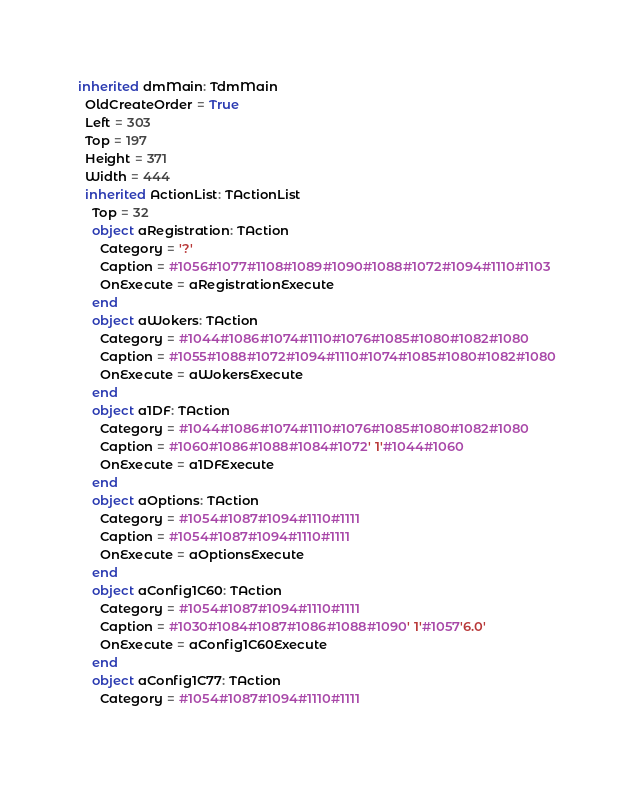Convert code to text. <code><loc_0><loc_0><loc_500><loc_500><_Pascal_>inherited dmMain: TdmMain
  OldCreateOrder = True
  Left = 303
  Top = 197
  Height = 371
  Width = 444
  inherited ActionList: TActionList
    Top = 32
    object aRegistration: TAction
      Category = '?'
      Caption = #1056#1077#1108#1089#1090#1088#1072#1094#1110#1103
      OnExecute = aRegistrationExecute
    end
    object aWokers: TAction
      Category = #1044#1086#1074#1110#1076#1085#1080#1082#1080
      Caption = #1055#1088#1072#1094#1110#1074#1085#1080#1082#1080
      OnExecute = aWokersExecute
    end
    object a1DF: TAction
      Category = #1044#1086#1074#1110#1076#1085#1080#1082#1080
      Caption = #1060#1086#1088#1084#1072' 1'#1044#1060
      OnExecute = a1DFExecute
    end
    object aOptions: TAction
      Category = #1054#1087#1094#1110#1111
      Caption = #1054#1087#1094#1110#1111
      OnExecute = aOptionsExecute
    end
    object aConfig1C60: TAction
      Category = #1054#1087#1094#1110#1111
      Caption = #1030#1084#1087#1086#1088#1090' 1'#1057'6.0'
      OnExecute = aConfig1C60Execute
    end
    object aConfig1C77: TAction
      Category = #1054#1087#1094#1110#1111</code> 